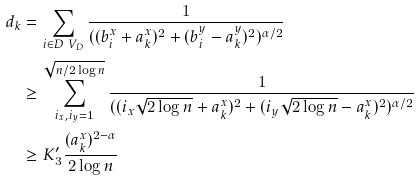<formula> <loc_0><loc_0><loc_500><loc_500>d _ { k } & = \sum _ { i \in D \ V _ { D } } \frac { 1 } { ( ( b ^ { x } _ { i } + a ^ { x } _ { k } ) ^ { 2 } + ( b ^ { y } _ { i } - a ^ { y } _ { k } ) ^ { 2 } ) ^ { \alpha / 2 } } \\ & \geq \sum _ { i _ { x } , i _ { y } = 1 } ^ { \sqrt { n / 2 \log n } } \frac { 1 } { ( ( i _ { x } \sqrt { 2 \log n } + a ^ { x } _ { k } ) ^ { 2 } + ( i _ { y } \sqrt { 2 \log n } - a ^ { x } _ { k } ) ^ { 2 } ) ^ { \alpha / 2 } } \\ & \geq K _ { 3 } ^ { \prime } \frac { ( a ^ { x } _ { k } ) ^ { 2 - \alpha } } { 2 \log n }</formula> 